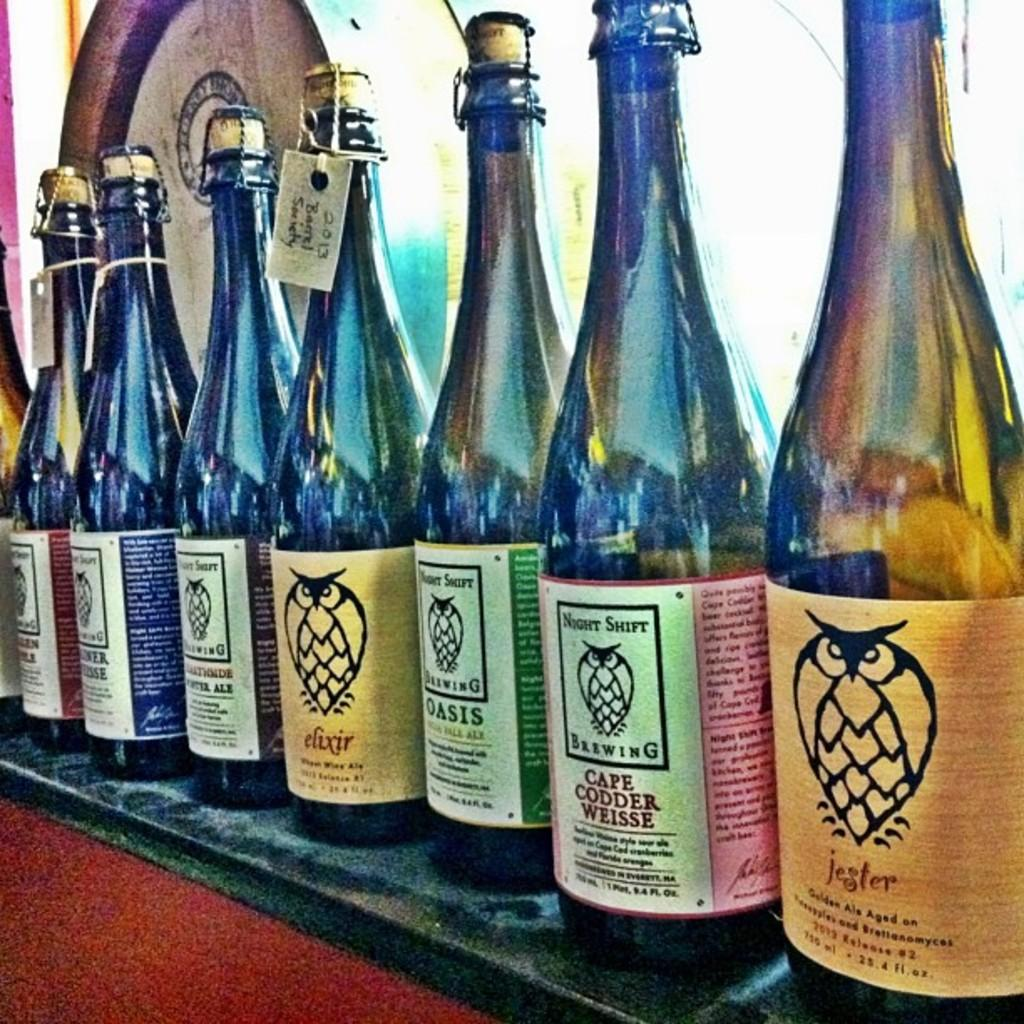Provide a one-sentence caption for the provided image. A row of wine bottles on a shelf made by Night Shift Brewing. 